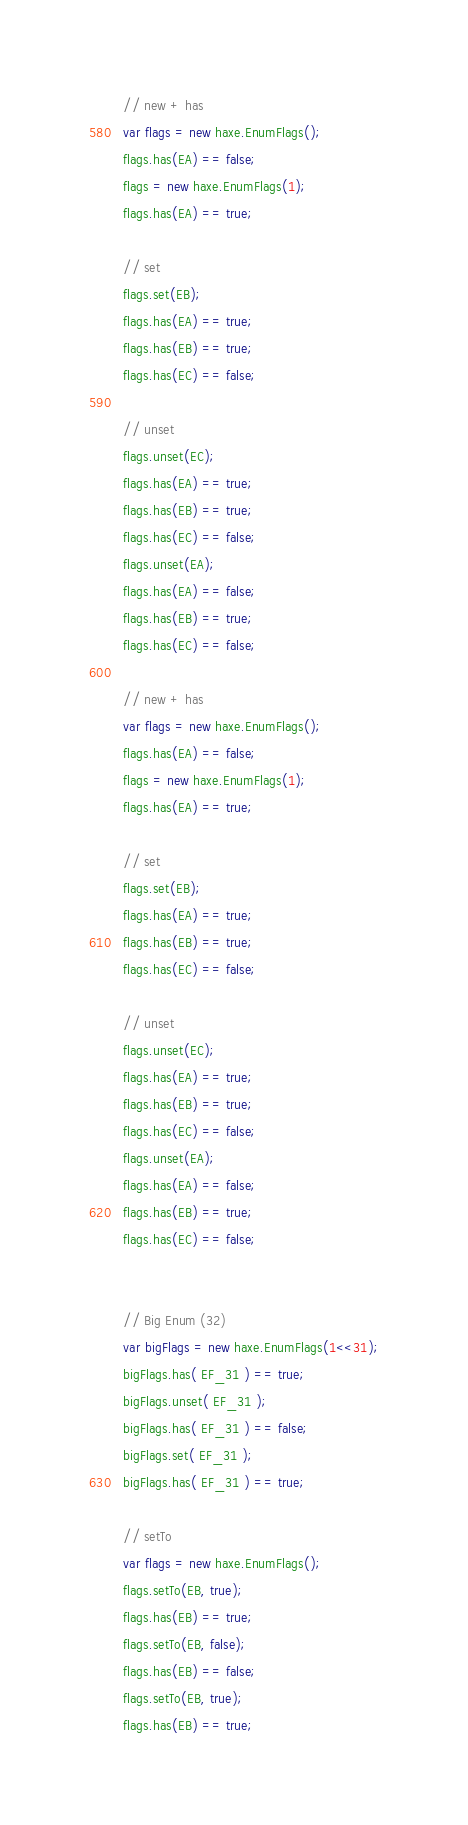<code> <loc_0><loc_0><loc_500><loc_500><_Haxe_>// new + has
var flags = new haxe.EnumFlags();
flags.has(EA) == false;
flags = new haxe.EnumFlags(1);
flags.has(EA) == true;

// set
flags.set(EB);
flags.has(EA) == true;
flags.has(EB) == true;
flags.has(EC) == false;

// unset
flags.unset(EC);
flags.has(EA) == true;
flags.has(EB) == true;
flags.has(EC) == false;
flags.unset(EA);
flags.has(EA) == false;
flags.has(EB) == true;
flags.has(EC) == false;

// new + has
var flags = new haxe.EnumFlags();
flags.has(EA) == false;
flags = new haxe.EnumFlags(1);
flags.has(EA) == true;

// set
flags.set(EB);
flags.has(EA) == true;
flags.has(EB) == true;
flags.has(EC) == false;

// unset
flags.unset(EC);
flags.has(EA) == true;
flags.has(EB) == true;
flags.has(EC) == false;
flags.unset(EA);
flags.has(EA) == false;
flags.has(EB) == true;
flags.has(EC) == false;


// Big Enum (32)
var bigFlags = new haxe.EnumFlags(1<<31);
bigFlags.has( EF_31 ) == true;
bigFlags.unset( EF_31 );
bigFlags.has( EF_31 ) == false;
bigFlags.set( EF_31 );
bigFlags.has( EF_31 ) == true;

// setTo
var flags = new haxe.EnumFlags();
flags.setTo(EB, true);
flags.has(EB) == true;
flags.setTo(EB, false);
flags.has(EB) == false;
flags.setTo(EB, true);
flags.has(EB) == true;</code> 